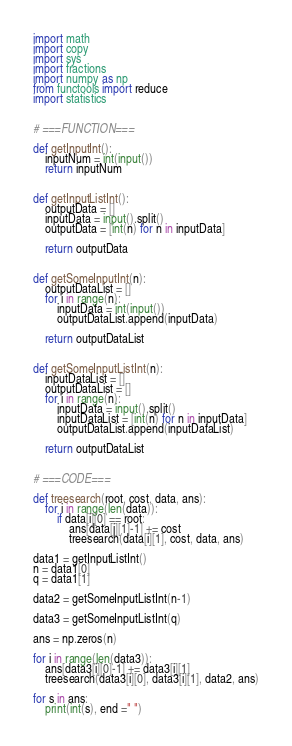<code> <loc_0><loc_0><loc_500><loc_500><_Python_>import math
import copy
import sys
import fractions
import numpy as np
from functools import reduce
import statistics


# ===FUNCTION===

def getInputInt():
    inputNum = int(input())
    return inputNum


def getInputListInt():
    outputData = []
    inputData = input().split()
    outputData = [int(n) for n in inputData]

    return outputData


def getSomeInputInt(n):
    outputDataList = []
    for i in range(n):
        inputData = int(input())
        outputDataList.append(inputData)

    return outputDataList


def getSomeInputListInt(n):
    inputDataList = []
    outputDataList = []
    for i in range(n):
        inputData = input().split()
        inputDataList = [int(n) for n in inputData]
        outputDataList.append(inputDataList)

    return outputDataList


# ===CODE===

def treesearch(root, cost, data, ans):
    for i in range(len(data)):
        if data[i][0] == root:
            ans[data[i][1]-1] += cost
            treesearch(data[i][1], cost, data, ans)

data1 = getInputListInt()
n = data1[0]
q = data1[1]

data2 = getSomeInputListInt(n-1)

data3 = getSomeInputListInt(q)

ans = np.zeros(n)

for i in range(len(data3)):
    ans[data3[i][0]-1] += data3[i][1]
    treesearch(data3[i][0], data3[i][1], data2, ans)

for s in ans:
    print(int(s), end =" ")

</code> 